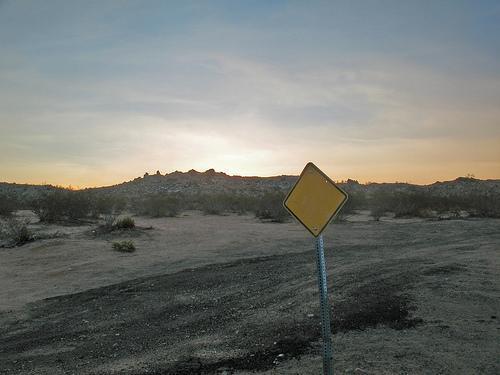How many signs are there?
Give a very brief answer. 1. 